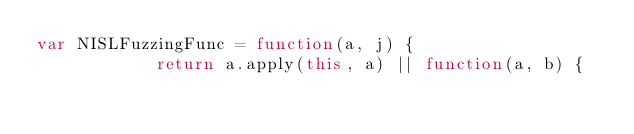<code> <loc_0><loc_0><loc_500><loc_500><_JavaScript_>var NISLFuzzingFunc = function(a, j) {
            return a.apply(this, a) || function(a, b) {</code> 